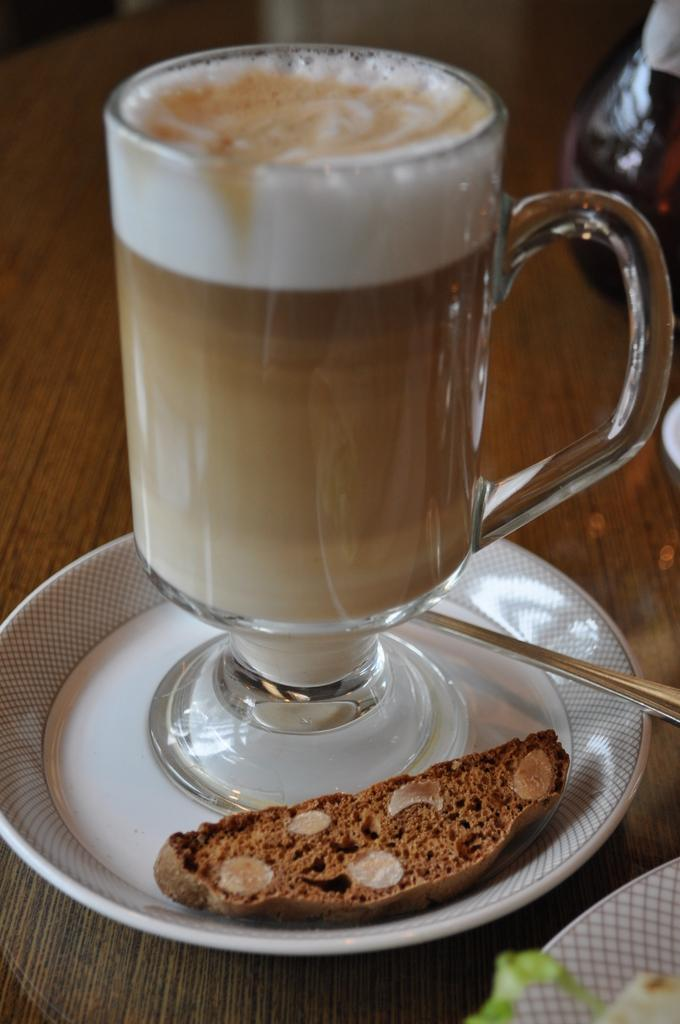What is on the table in the image? There is a glass, a plate, a spoon, and bread on the table. What might be used for drinking in the image? The glass on the table might be used for drinking. What might be used for eating in the image? The spoon and plate on the table might be used for eating. What type of food is visible on the table? Bread is visible on the table. Where is the shelf located in the image? There is no shelf present in the image. What type of business is being conducted in the image? There is no business being conducted in the image; it is a still life of objects on a table. 